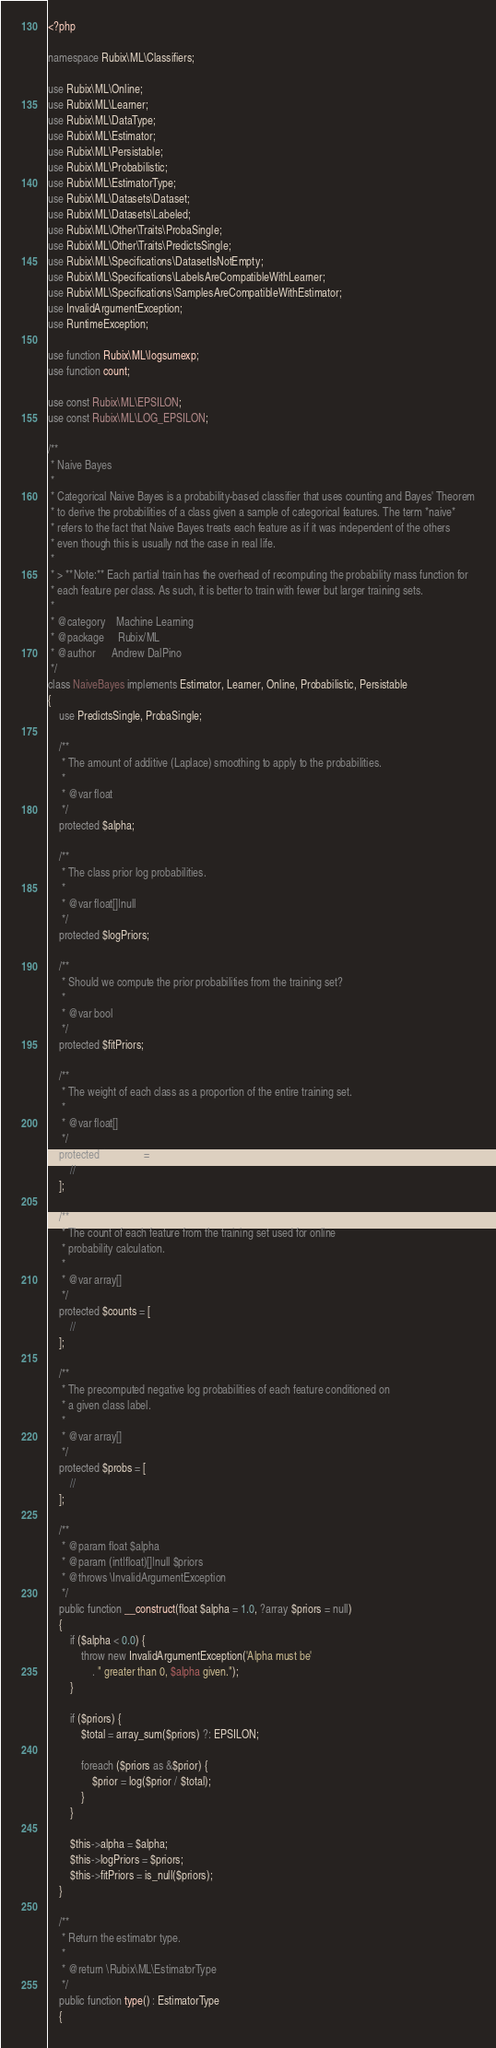<code> <loc_0><loc_0><loc_500><loc_500><_PHP_><?php

namespace Rubix\ML\Classifiers;

use Rubix\ML\Online;
use Rubix\ML\Learner;
use Rubix\ML\DataType;
use Rubix\ML\Estimator;
use Rubix\ML\Persistable;
use Rubix\ML\Probabilistic;
use Rubix\ML\EstimatorType;
use Rubix\ML\Datasets\Dataset;
use Rubix\ML\Datasets\Labeled;
use Rubix\ML\Other\Traits\ProbaSingle;
use Rubix\ML\Other\Traits\PredictsSingle;
use Rubix\ML\Specifications\DatasetIsNotEmpty;
use Rubix\ML\Specifications\LabelsAreCompatibleWithLearner;
use Rubix\ML\Specifications\SamplesAreCompatibleWithEstimator;
use InvalidArgumentException;
use RuntimeException;

use function Rubix\ML\logsumexp;
use function count;

use const Rubix\ML\EPSILON;
use const Rubix\ML\LOG_EPSILON;

/**
 * Naive Bayes
 *
 * Categorical Naive Bayes is a probability-based classifier that uses counting and Bayes' Theorem
 * to derive the probabilities of a class given a sample of categorical features. The term *naive*
 * refers to the fact that Naive Bayes treats each feature as if it was independent of the others
 * even though this is usually not the case in real life.
 *
 * > **Note:** Each partial train has the overhead of recomputing the probability mass function for
 * each feature per class. As such, it is better to train with fewer but larger training sets.
 *
 * @category    Machine Learning
 * @package     Rubix/ML
 * @author      Andrew DalPino
 */
class NaiveBayes implements Estimator, Learner, Online, Probabilistic, Persistable
{
    use PredictsSingle, ProbaSingle;
    
    /**
     * The amount of additive (Laplace) smoothing to apply to the probabilities.
     *
     * @var float
     */
    protected $alpha;

    /**
     * The class prior log probabilities.
     *
     * @var float[]|null
     */
    protected $logPriors;

    /**
     * Should we compute the prior probabilities from the training set?
     *
     * @var bool
     */
    protected $fitPriors;

    /**
     * The weight of each class as a proportion of the entire training set.
     *
     * @var float[]
     */
    protected $weights = [
        //
    ];

    /**
     * The count of each feature from the training set used for online
     * probability calculation.
     *
     * @var array[]
     */
    protected $counts = [
        //
    ];

    /**
     * The precomputed negative log probabilities of each feature conditioned on
     * a given class label.
     *
     * @var array[]
     */
    protected $probs = [
        //
    ];

    /**
     * @param float $alpha
     * @param (int|float)[]|null $priors
     * @throws \InvalidArgumentException
     */
    public function __construct(float $alpha = 1.0, ?array $priors = null)
    {
        if ($alpha < 0.0) {
            throw new InvalidArgumentException('Alpha must be'
                . " greater than 0, $alpha given.");
        }

        if ($priors) {
            $total = array_sum($priors) ?: EPSILON;

            foreach ($priors as &$prior) {
                $prior = log($prior / $total);
            }
        }
        
        $this->alpha = $alpha;
        $this->logPriors = $priors;
        $this->fitPriors = is_null($priors);
    }

    /**
     * Return the estimator type.
     *
     * @return \Rubix\ML\EstimatorType
     */
    public function type() : EstimatorType
    {</code> 